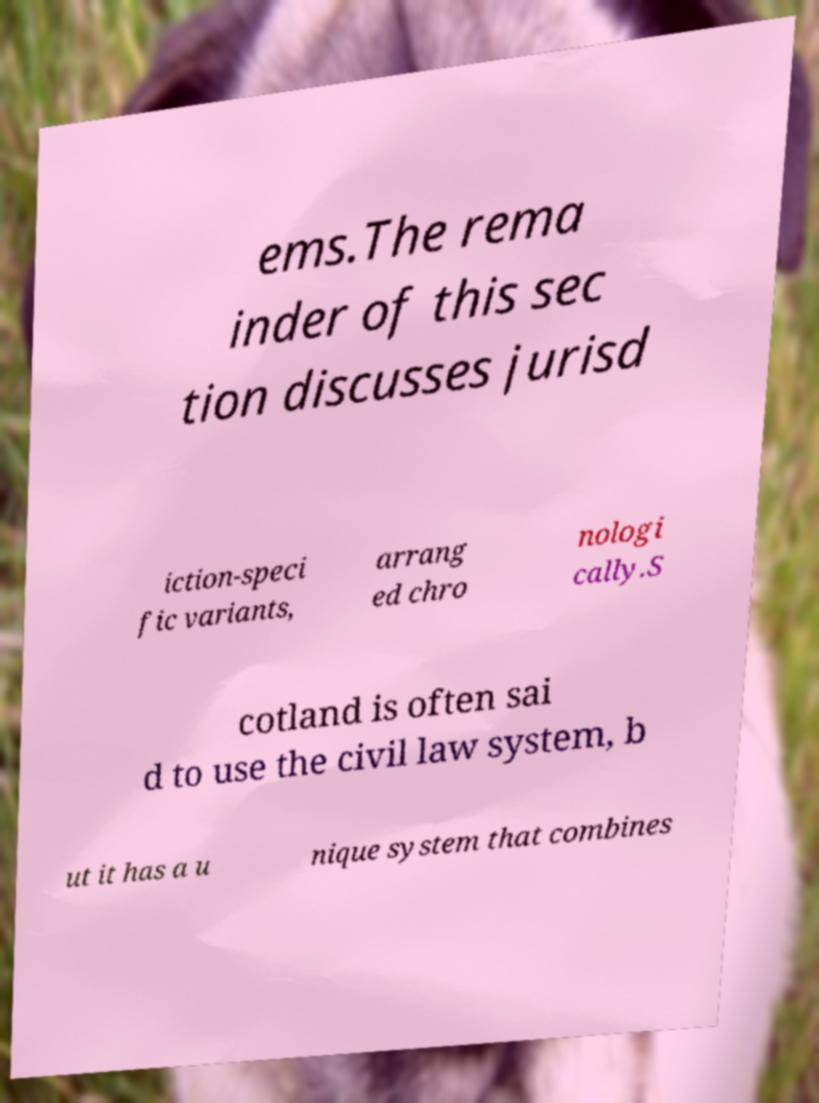I need the written content from this picture converted into text. Can you do that? ems.The rema inder of this sec tion discusses jurisd iction-speci fic variants, arrang ed chro nologi cally.S cotland is often sai d to use the civil law system, b ut it has a u nique system that combines 